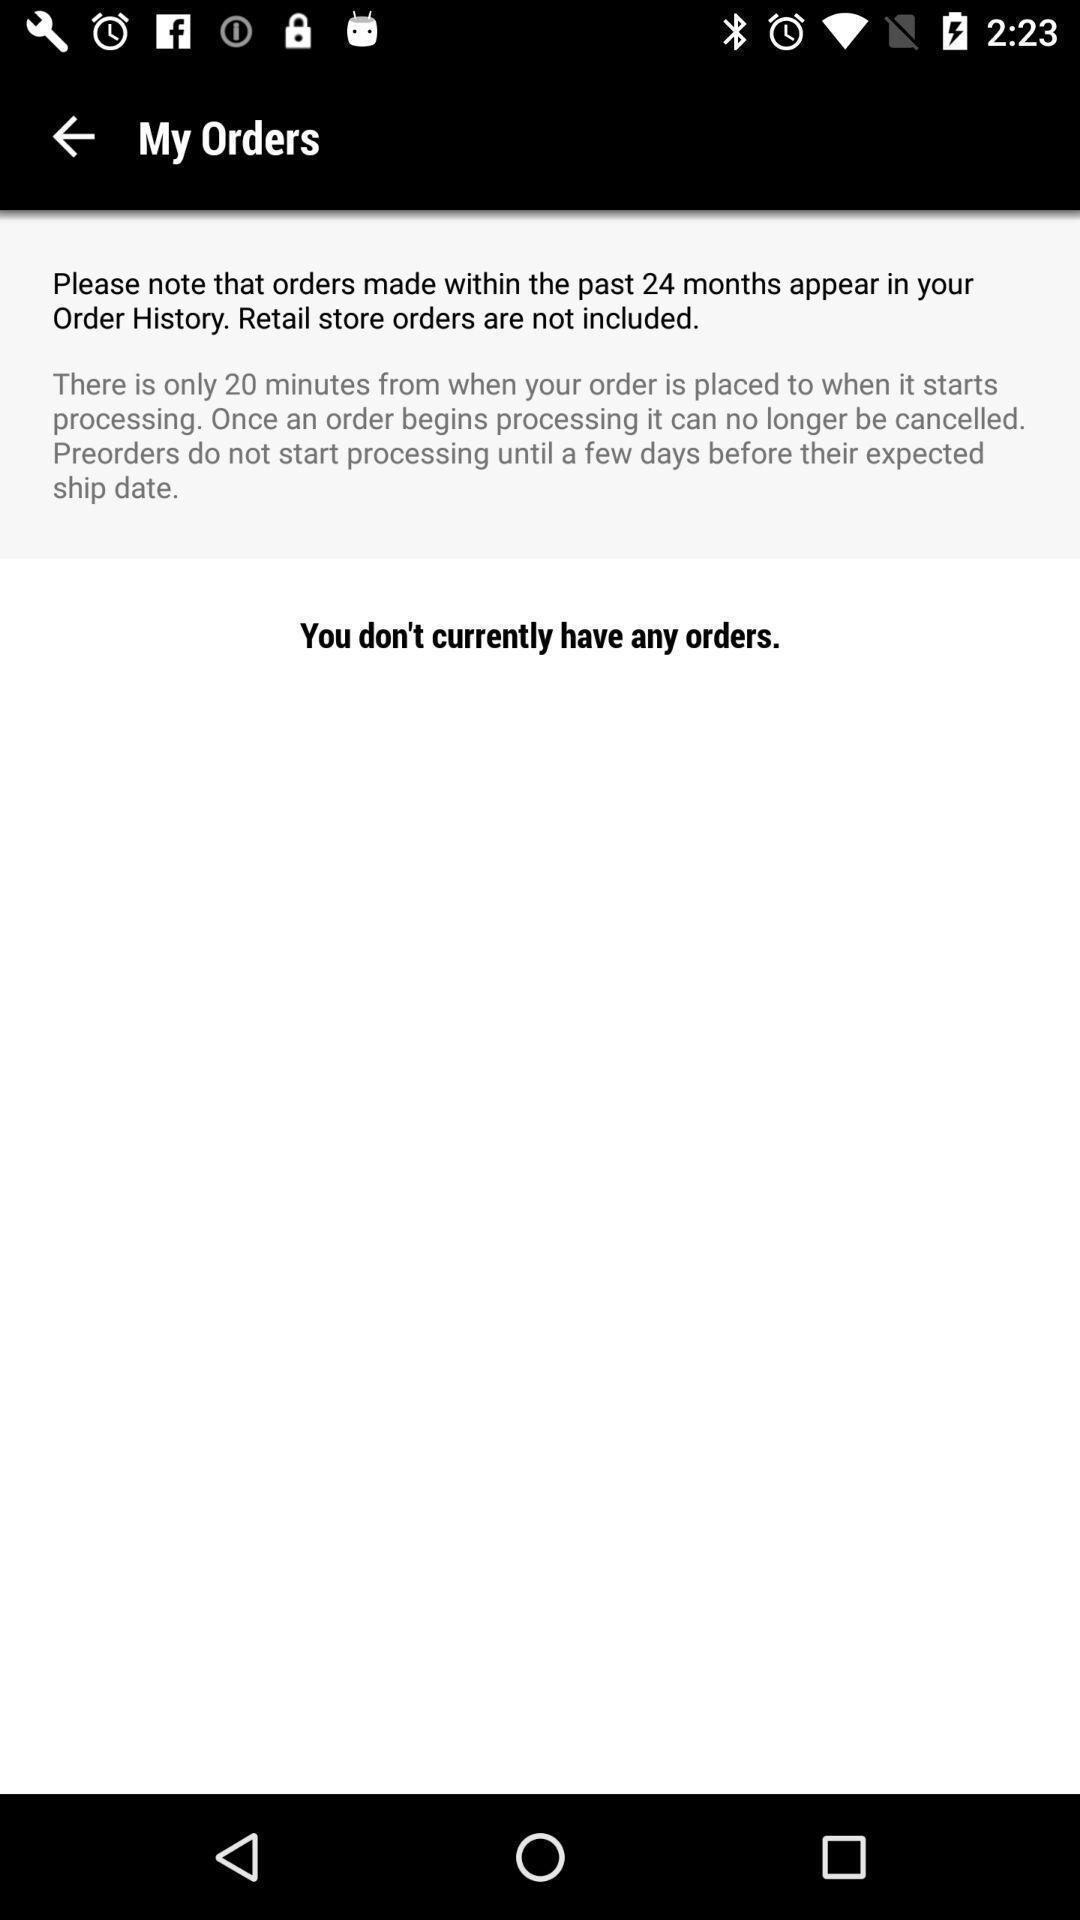What is the overall content of this screenshot? Page displaying you do n't have any orders. 